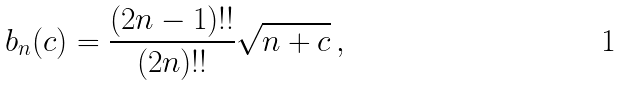Convert formula to latex. <formula><loc_0><loc_0><loc_500><loc_500>b _ { n } ( c ) = \frac { ( 2 n - 1 ) ! ! } { ( 2 n ) ! ! } \sqrt { n + c } \, ,</formula> 